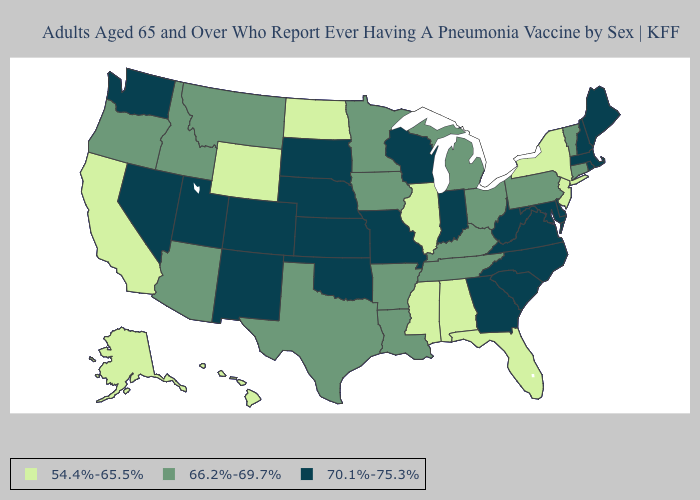What is the highest value in the Northeast ?
Be succinct. 70.1%-75.3%. What is the lowest value in the West?
Write a very short answer. 54.4%-65.5%. Name the states that have a value in the range 54.4%-65.5%?
Answer briefly. Alabama, Alaska, California, Florida, Hawaii, Illinois, Mississippi, New Jersey, New York, North Dakota, Wyoming. Name the states that have a value in the range 66.2%-69.7%?
Write a very short answer. Arizona, Arkansas, Connecticut, Idaho, Iowa, Kentucky, Louisiana, Michigan, Minnesota, Montana, Ohio, Oregon, Pennsylvania, Tennessee, Texas, Vermont. Does Wisconsin have the highest value in the USA?
Concise answer only. Yes. How many symbols are there in the legend?
Write a very short answer. 3. Does Massachusetts have a lower value than California?
Concise answer only. No. Does the first symbol in the legend represent the smallest category?
Short answer required. Yes. Name the states that have a value in the range 54.4%-65.5%?
Quick response, please. Alabama, Alaska, California, Florida, Hawaii, Illinois, Mississippi, New Jersey, New York, North Dakota, Wyoming. What is the value of New York?
Answer briefly. 54.4%-65.5%. What is the value of Kansas?
Quick response, please. 70.1%-75.3%. What is the value of Nevada?
Give a very brief answer. 70.1%-75.3%. Among the states that border North Dakota , which have the highest value?
Concise answer only. South Dakota. Does Iowa have a lower value than South Carolina?
Keep it brief. Yes. Name the states that have a value in the range 66.2%-69.7%?
Keep it brief. Arizona, Arkansas, Connecticut, Idaho, Iowa, Kentucky, Louisiana, Michigan, Minnesota, Montana, Ohio, Oregon, Pennsylvania, Tennessee, Texas, Vermont. 